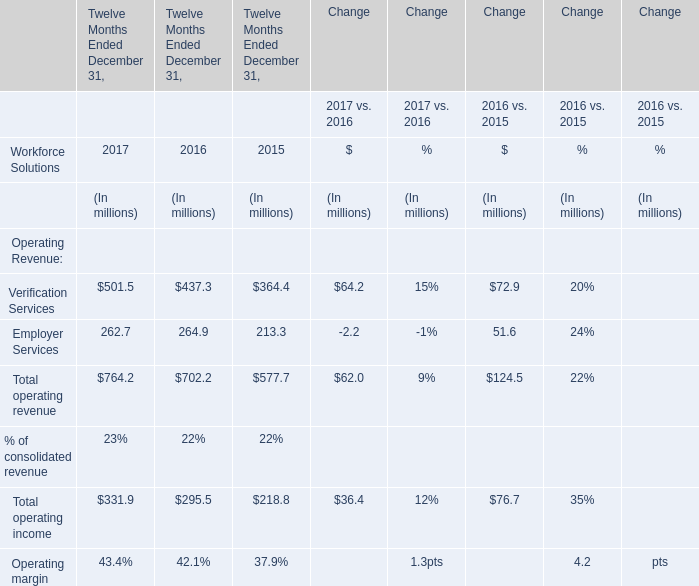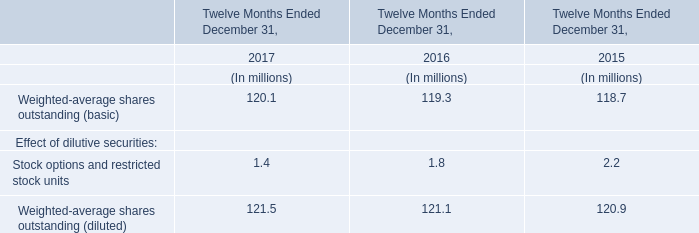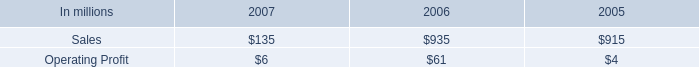Does the proportion of Verification Services in total larger than that ofEmployer Services in 2017? (in million) 
Answer: 501.5. 